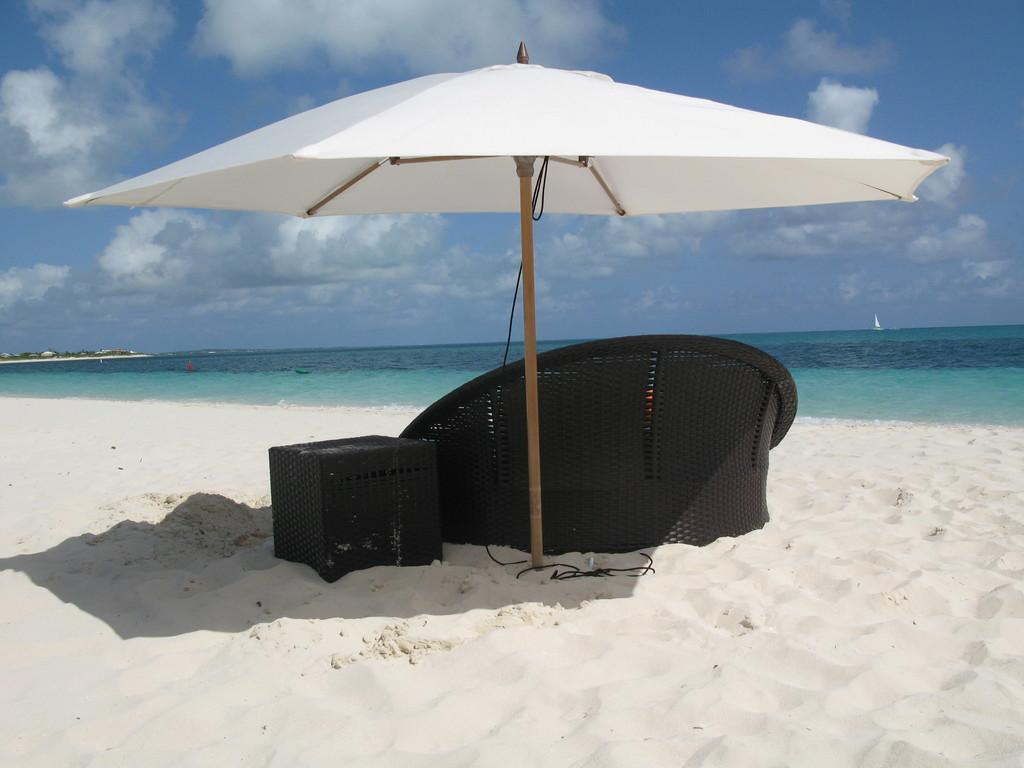What object is present in the image that can provide shelter from the rain? There is an umbrella in the image that can provide shelter from the rain. What type of furniture is visible in the image? There is a chair in the image. What type of electrical connection is present in the image? There is a cable in the image. What unidentified object is present in the image? There is an unspecified object in the image. What is visible in the background of the image? There is a boat on water and sky visible in the background of the image. What type of weather can be inferred from the presence of clouds in the sky? Clouds are present in the sky, which suggests that the weather might be overcast or cloudy. What type of food can be seen in the stomach of the person in the image? There is no person present in the image, and therefore no stomach or food can be observed. 